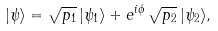<formula> <loc_0><loc_0><loc_500><loc_500>| \psi \rangle = \sqrt { p _ { 1 } } \, | \psi _ { 1 } \rangle + e ^ { i \phi } \, \sqrt { p _ { 2 } } \, | \psi _ { 2 } \rangle ,</formula> 